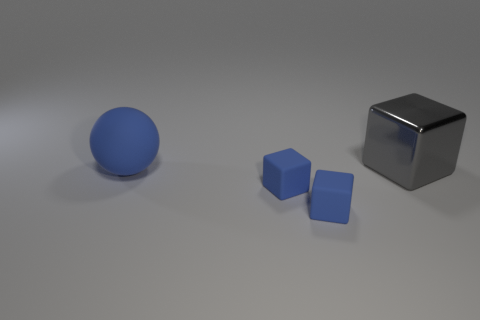What color is the thing behind the big thing that is in front of the big thing behind the large blue object?
Offer a very short reply. Gray. Is the large metallic thing the same shape as the big blue matte object?
Offer a terse response. No. There is a big object to the left of the gray shiny block; does it have the same color as the cube behind the large blue object?
Offer a terse response. No. There is a big object that is in front of the block behind the big sphere; what is its shape?
Your response must be concise. Sphere. Is the material of the block that is behind the blue matte ball the same as the large object that is in front of the big shiny thing?
Your response must be concise. No. There is a block behind the large sphere; how many large blue matte spheres are behind it?
Give a very brief answer. 0. Does the large thing that is in front of the metal block have the same shape as the big object behind the matte sphere?
Give a very brief answer. No. There is a big thing behind the big object in front of the large shiny object; what is its color?
Your answer should be compact. Gray. What shape is the large object right of the large object left of the large thing right of the ball?
Your answer should be very brief. Cube. What is the size of the gray metal cube?
Keep it short and to the point. Large. 